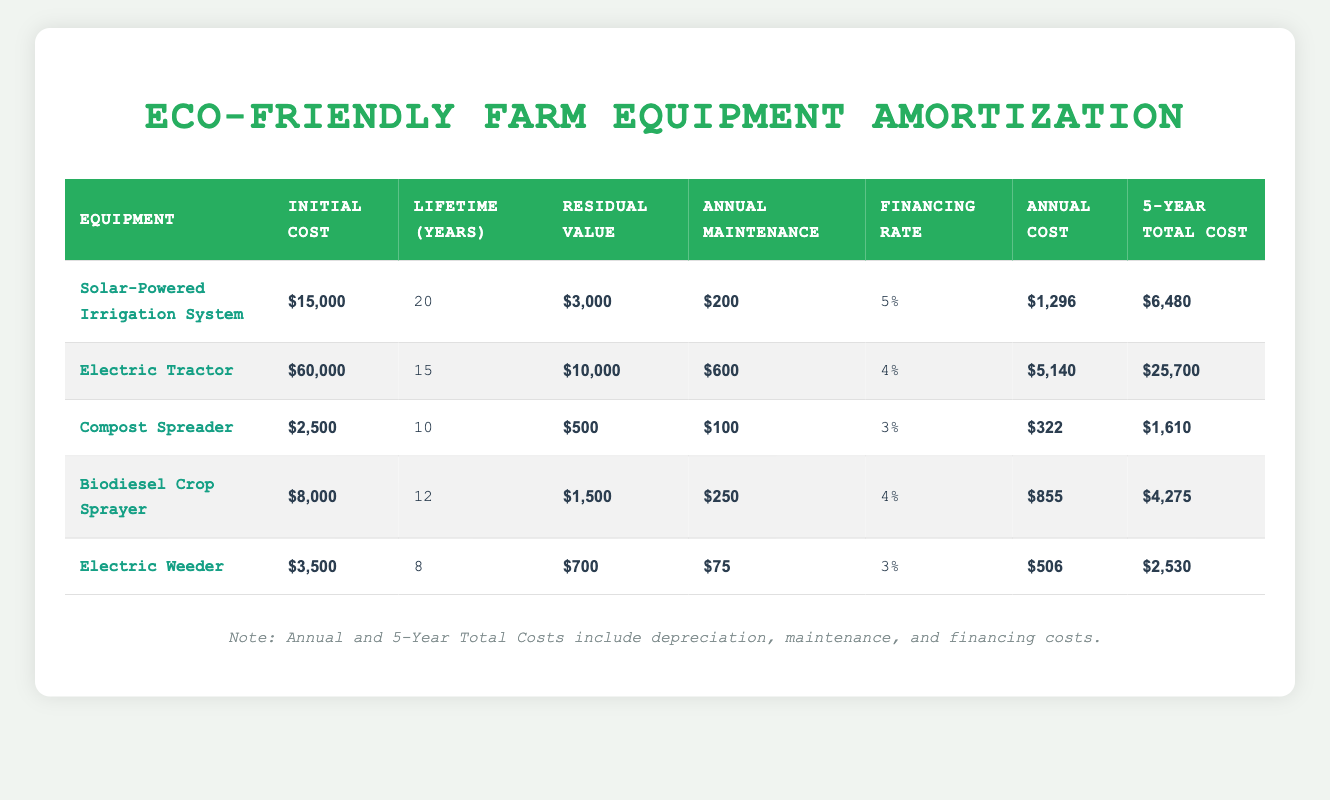What is the initial cost of the Electric Tractor? The initial cost is listed in the table under the "Initial Cost" column for the Electric Tractor row. It clearly states that the initial cost is $60,000.
Answer: $60,000 Which equipment has the lowest annual maintenance cost? By comparing the "Annual Maintenance" column values for each equipment, the Electric Weeder has the lowest annual maintenance cost of $75, which is lower than the others.
Answer: $75 What is the total cost of the Solar-Powered Irrigation System over 5 years? The "5-Year Total Cost" for the Solar-Powered Irrigation System is $6,480. This amount encompasses both depreciation and maintenance costs over that period, as shown in the table.
Answer: $6,480 Which equipment has the highest financing rate, and what is that rate? Looking at the "Financing Rate" column, the Electric Tractor has the highest financing rate at 4%. This is the highest percentage compared to other equipment rates displayed in the table.
Answer: 4% If I sum up the annual costs of the Compost Spreader and the Biodiesel Crop Sprayer, what will the total be? The annual cost for the Compost Spreader is $322 and for the Biodiesel Crop Sprayer is $855. Adding these two gives a total of 322 + 855 = $1,177.
Answer: $1,177 Is the residual value of the Electric Weeder higher than that of the Compost Spreader? The residual value for the Electric Weeder is $700, while for the Compost Spreader it is $500. Since $700 is greater than $500, the statement is true.
Answer: Yes What is the average annual cost of all the equipment listed? The annual costs are $1,296, $5,140, $322, $855, and $506. Summing these gives 1,296 + 5,140 + 322 + 855 + 506 = $8,119. Dividing by 5 (the number of equipment) gives an average of $1,623.80.
Answer: $1,623.80 What equipment's total cost over 5 years exceeds $5,000? Checking the "5-Year Total Cost" column, the Electric Tractor ($25,700), the Solar-Powered Irrigation System ($6,480), the Biodiesel Crop Sprayer ($4,275) and the Electric Weeder ($2,530) exceed $5,000, whereas the Compost Spreader does not.
Answer: Electric Tractor, Solar-Powered Irrigation System How much more does the Electric Tractor cost per year compared to the Compost Spreader? The annual cost for the Electric Tractor is $5,140, and for the Compost Spreader, it's $322. The difference is 5,140 - 322 = $4,818.
Answer: $4,818 